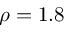<formula> <loc_0><loc_0><loc_500><loc_500>\rho = 1 . 8</formula> 